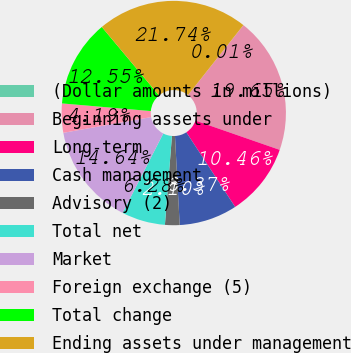Convert chart. <chart><loc_0><loc_0><loc_500><loc_500><pie_chart><fcel>(Dollar amounts in millions)<fcel>Beginning assets under<fcel>Long-term<fcel>Cash management<fcel>Advisory (2)<fcel>Total net<fcel>Market<fcel>Foreign exchange (5)<fcel>Total change<fcel>Ending assets under management<nl><fcel>0.01%<fcel>19.65%<fcel>10.46%<fcel>8.37%<fcel>2.1%<fcel>6.28%<fcel>14.64%<fcel>4.19%<fcel>12.55%<fcel>21.74%<nl></chart> 